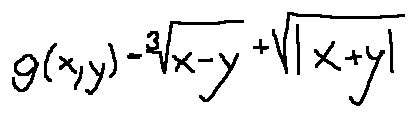Convert formula to latex. <formula><loc_0><loc_0><loc_500><loc_500>g ( x , y ) = \sqrt { [ } 3 ] { x - y } + \sqrt { | x + y | }</formula> 